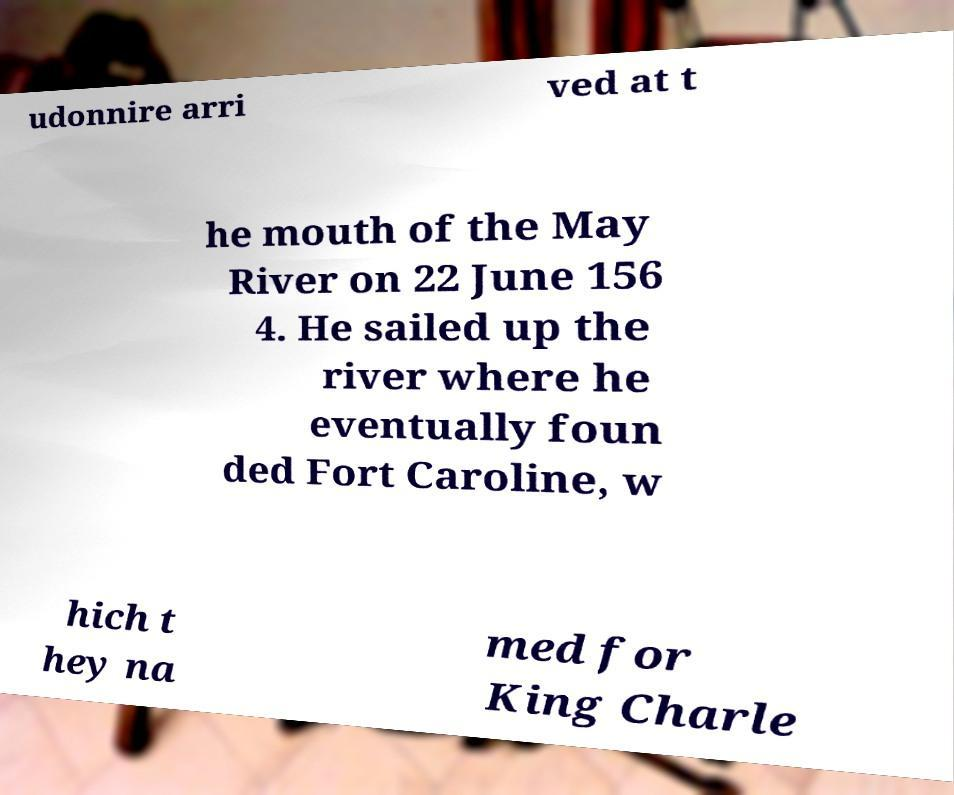Please read and relay the text visible in this image. What does it say? udonnire arri ved at t he mouth of the May River on 22 June 156 4. He sailed up the river where he eventually foun ded Fort Caroline, w hich t hey na med for King Charle 